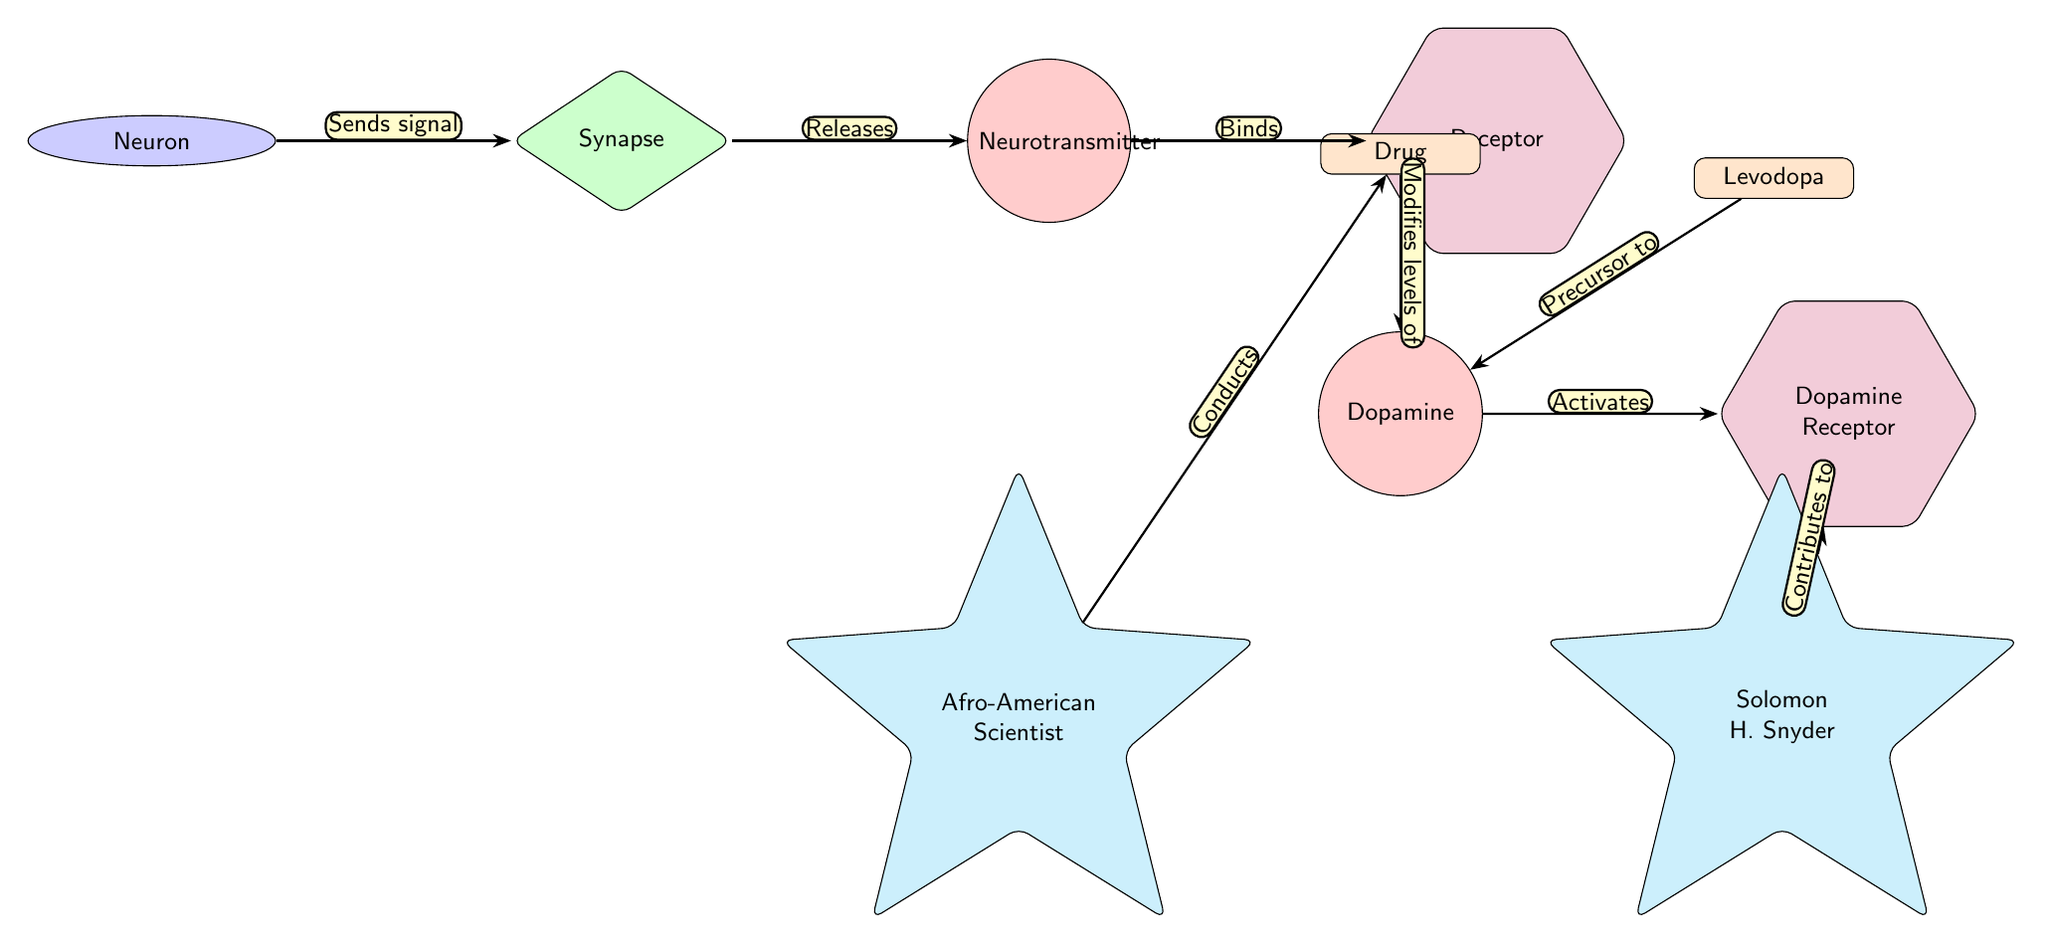What is the first node in the pathway? The first node in the diagram is labeled "Neuron." From the leftmost side of the diagram, it is the starting point of the signaling pathway indicated in the flow.
Answer: Neuron How many drugs are represented in the diagram? The diagram features two drug nodes: one labeled "Drug" and another labeled "Levodopa." To determine the answer, we can visually count the distinct drug nodes within the diagram.
Answer: 2 What type of node is "Dopamine"? "Dopamine" is represented as a molecule in the diagram. It is indicated by the circular shape and red color, which is specific to the molecule node style defined in the diagram.
Answer: Molecule What action does the "Drug" perform? The "Drug" node is shown to "Modifies levels of" dopamine, which is indicated by the edge connecting the drug to dopamine, describing the relationship and its effect.
Answer: Modifies levels of Who is connected to the "Dopamine Receptor" node? "Solomon H. Snyder" is connected to the "Dopamine Receptor" node, as is shown by the directed edge labeled "Contributes to," illustrating his contribution to that specific receptor.
Answer: Solomon H. Snyder What is the relationship between "Dopamine" and "Dopamine Receptor"? The relationship is characterized as "Activates," indicating that dopamine interacts with and activates the dopamine receptor. This is shown by the edge drawn from dopamine to the dopamine receptor with this label.
Answer: Activates Which node acts as a precursor to "Dopamine"? "Levodopa" acts as a precursor to dopamine, as indicated by the directed edge labeled "Precursor to" from the levodopa node toward the dopamine molecule node in the diagram.
Answer: Levodopa What does the "Afro-American Scientist" node conduct? The "Afro-American Scientist" node conducts the "Drug," as depicted by the edge labeled "Conducts." This shows their role in the context of this part of the biochemical pathway.
Answer: Drug How many neurotransmitters are shown in the diagram? The diagram indicates one neurotransmitter node labeled "Neurotransmitter," and we can see this singular node positioned in the pathway flow visually.
Answer: 1 What color represents the scientists in the diagram? Scientists in the diagram are represented by the cyan color, specifically shown in the node style for "scientist." This distinctive color helps identify the role of scientists within the biochemical context.
Answer: Cyan 